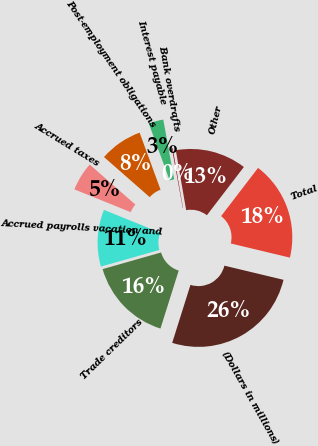Convert chart. <chart><loc_0><loc_0><loc_500><loc_500><pie_chart><fcel>(Dollars in millions)<fcel>Trade creditors<fcel>Accrued payrolls vacation and<fcel>Accrued taxes<fcel>Post-employment obligations<fcel>Interest payable<fcel>Bank overdrafts<fcel>Other<fcel>Total<nl><fcel>26.12%<fcel>15.73%<fcel>10.53%<fcel>5.34%<fcel>7.94%<fcel>2.74%<fcel>0.14%<fcel>13.13%<fcel>18.33%<nl></chart> 